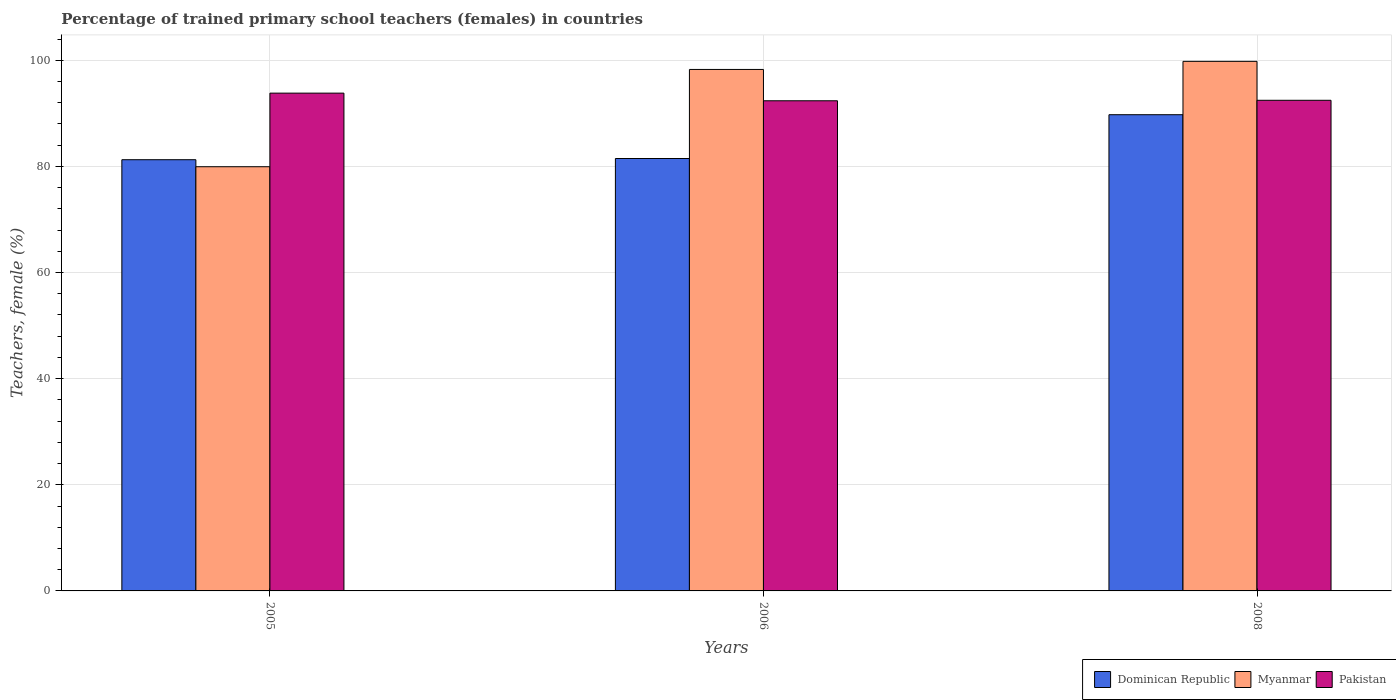How many groups of bars are there?
Give a very brief answer. 3. Are the number of bars per tick equal to the number of legend labels?
Your answer should be compact. Yes. How many bars are there on the 2nd tick from the right?
Your answer should be very brief. 3. In how many cases, is the number of bars for a given year not equal to the number of legend labels?
Provide a succinct answer. 0. What is the percentage of trained primary school teachers (females) in Myanmar in 2005?
Ensure brevity in your answer.  79.94. Across all years, what is the maximum percentage of trained primary school teachers (females) in Pakistan?
Your answer should be very brief. 93.81. Across all years, what is the minimum percentage of trained primary school teachers (females) in Pakistan?
Your response must be concise. 92.37. What is the total percentage of trained primary school teachers (females) in Pakistan in the graph?
Your answer should be very brief. 278.64. What is the difference between the percentage of trained primary school teachers (females) in Pakistan in 2006 and that in 2008?
Provide a short and direct response. -0.09. What is the difference between the percentage of trained primary school teachers (females) in Dominican Republic in 2008 and the percentage of trained primary school teachers (females) in Myanmar in 2006?
Provide a short and direct response. -8.53. What is the average percentage of trained primary school teachers (females) in Pakistan per year?
Keep it short and to the point. 92.88. In the year 2008, what is the difference between the percentage of trained primary school teachers (females) in Myanmar and percentage of trained primary school teachers (females) in Pakistan?
Ensure brevity in your answer.  7.34. What is the ratio of the percentage of trained primary school teachers (females) in Myanmar in 2005 to that in 2008?
Give a very brief answer. 0.8. What is the difference between the highest and the second highest percentage of trained primary school teachers (females) in Dominican Republic?
Your response must be concise. 8.25. What is the difference between the highest and the lowest percentage of trained primary school teachers (females) in Myanmar?
Your answer should be very brief. 19.86. In how many years, is the percentage of trained primary school teachers (females) in Myanmar greater than the average percentage of trained primary school teachers (females) in Myanmar taken over all years?
Ensure brevity in your answer.  2. What does the 1st bar from the left in 2005 represents?
Provide a short and direct response. Dominican Republic. What does the 1st bar from the right in 2008 represents?
Ensure brevity in your answer.  Pakistan. Is it the case that in every year, the sum of the percentage of trained primary school teachers (females) in Dominican Republic and percentage of trained primary school teachers (females) in Pakistan is greater than the percentage of trained primary school teachers (females) in Myanmar?
Ensure brevity in your answer.  Yes. How many bars are there?
Make the answer very short. 9. How many years are there in the graph?
Your answer should be compact. 3. What is the difference between two consecutive major ticks on the Y-axis?
Keep it short and to the point. 20. Are the values on the major ticks of Y-axis written in scientific E-notation?
Make the answer very short. No. Does the graph contain any zero values?
Your answer should be compact. No. Where does the legend appear in the graph?
Your answer should be very brief. Bottom right. How are the legend labels stacked?
Make the answer very short. Horizontal. What is the title of the graph?
Keep it short and to the point. Percentage of trained primary school teachers (females) in countries. What is the label or title of the X-axis?
Ensure brevity in your answer.  Years. What is the label or title of the Y-axis?
Provide a succinct answer. Teachers, female (%). What is the Teachers, female (%) in Dominican Republic in 2005?
Your response must be concise. 81.26. What is the Teachers, female (%) in Myanmar in 2005?
Give a very brief answer. 79.94. What is the Teachers, female (%) in Pakistan in 2005?
Your response must be concise. 93.81. What is the Teachers, female (%) of Dominican Republic in 2006?
Provide a succinct answer. 81.49. What is the Teachers, female (%) in Myanmar in 2006?
Your answer should be very brief. 98.27. What is the Teachers, female (%) in Pakistan in 2006?
Give a very brief answer. 92.37. What is the Teachers, female (%) of Dominican Republic in 2008?
Your answer should be very brief. 89.74. What is the Teachers, female (%) of Myanmar in 2008?
Your answer should be compact. 99.8. What is the Teachers, female (%) of Pakistan in 2008?
Your answer should be very brief. 92.46. Across all years, what is the maximum Teachers, female (%) in Dominican Republic?
Ensure brevity in your answer.  89.74. Across all years, what is the maximum Teachers, female (%) of Myanmar?
Ensure brevity in your answer.  99.8. Across all years, what is the maximum Teachers, female (%) of Pakistan?
Give a very brief answer. 93.81. Across all years, what is the minimum Teachers, female (%) of Dominican Republic?
Give a very brief answer. 81.26. Across all years, what is the minimum Teachers, female (%) of Myanmar?
Offer a very short reply. 79.94. Across all years, what is the minimum Teachers, female (%) in Pakistan?
Offer a terse response. 92.37. What is the total Teachers, female (%) of Dominican Republic in the graph?
Offer a terse response. 252.49. What is the total Teachers, female (%) in Myanmar in the graph?
Offer a terse response. 278.01. What is the total Teachers, female (%) in Pakistan in the graph?
Your answer should be very brief. 278.64. What is the difference between the Teachers, female (%) of Dominican Republic in 2005 and that in 2006?
Your answer should be compact. -0.23. What is the difference between the Teachers, female (%) in Myanmar in 2005 and that in 2006?
Your answer should be very brief. -18.33. What is the difference between the Teachers, female (%) of Pakistan in 2005 and that in 2006?
Provide a succinct answer. 1.44. What is the difference between the Teachers, female (%) in Dominican Republic in 2005 and that in 2008?
Give a very brief answer. -8.48. What is the difference between the Teachers, female (%) of Myanmar in 2005 and that in 2008?
Give a very brief answer. -19.86. What is the difference between the Teachers, female (%) in Pakistan in 2005 and that in 2008?
Make the answer very short. 1.35. What is the difference between the Teachers, female (%) in Dominican Republic in 2006 and that in 2008?
Keep it short and to the point. -8.25. What is the difference between the Teachers, female (%) in Myanmar in 2006 and that in 2008?
Provide a succinct answer. -1.52. What is the difference between the Teachers, female (%) in Pakistan in 2006 and that in 2008?
Offer a terse response. -0.09. What is the difference between the Teachers, female (%) of Dominican Republic in 2005 and the Teachers, female (%) of Myanmar in 2006?
Ensure brevity in your answer.  -17.01. What is the difference between the Teachers, female (%) of Dominican Republic in 2005 and the Teachers, female (%) of Pakistan in 2006?
Offer a very short reply. -11.11. What is the difference between the Teachers, female (%) of Myanmar in 2005 and the Teachers, female (%) of Pakistan in 2006?
Provide a short and direct response. -12.43. What is the difference between the Teachers, female (%) in Dominican Republic in 2005 and the Teachers, female (%) in Myanmar in 2008?
Give a very brief answer. -18.54. What is the difference between the Teachers, female (%) in Dominican Republic in 2005 and the Teachers, female (%) in Pakistan in 2008?
Ensure brevity in your answer.  -11.2. What is the difference between the Teachers, female (%) of Myanmar in 2005 and the Teachers, female (%) of Pakistan in 2008?
Your answer should be compact. -12.52. What is the difference between the Teachers, female (%) of Dominican Republic in 2006 and the Teachers, female (%) of Myanmar in 2008?
Provide a succinct answer. -18.31. What is the difference between the Teachers, female (%) in Dominican Republic in 2006 and the Teachers, female (%) in Pakistan in 2008?
Your answer should be very brief. -10.97. What is the difference between the Teachers, female (%) in Myanmar in 2006 and the Teachers, female (%) in Pakistan in 2008?
Your response must be concise. 5.81. What is the average Teachers, female (%) of Dominican Republic per year?
Offer a terse response. 84.16. What is the average Teachers, female (%) in Myanmar per year?
Keep it short and to the point. 92.67. What is the average Teachers, female (%) of Pakistan per year?
Provide a short and direct response. 92.88. In the year 2005, what is the difference between the Teachers, female (%) in Dominican Republic and Teachers, female (%) in Myanmar?
Your answer should be compact. 1.32. In the year 2005, what is the difference between the Teachers, female (%) of Dominican Republic and Teachers, female (%) of Pakistan?
Provide a succinct answer. -12.55. In the year 2005, what is the difference between the Teachers, female (%) in Myanmar and Teachers, female (%) in Pakistan?
Make the answer very short. -13.87. In the year 2006, what is the difference between the Teachers, female (%) of Dominican Republic and Teachers, female (%) of Myanmar?
Provide a short and direct response. -16.79. In the year 2006, what is the difference between the Teachers, female (%) in Dominican Republic and Teachers, female (%) in Pakistan?
Provide a short and direct response. -10.88. In the year 2006, what is the difference between the Teachers, female (%) in Myanmar and Teachers, female (%) in Pakistan?
Offer a very short reply. 5.9. In the year 2008, what is the difference between the Teachers, female (%) of Dominican Republic and Teachers, female (%) of Myanmar?
Ensure brevity in your answer.  -10.05. In the year 2008, what is the difference between the Teachers, female (%) in Dominican Republic and Teachers, female (%) in Pakistan?
Provide a succinct answer. -2.72. In the year 2008, what is the difference between the Teachers, female (%) of Myanmar and Teachers, female (%) of Pakistan?
Offer a very short reply. 7.34. What is the ratio of the Teachers, female (%) of Myanmar in 2005 to that in 2006?
Ensure brevity in your answer.  0.81. What is the ratio of the Teachers, female (%) in Pakistan in 2005 to that in 2006?
Ensure brevity in your answer.  1.02. What is the ratio of the Teachers, female (%) in Dominican Republic in 2005 to that in 2008?
Your response must be concise. 0.91. What is the ratio of the Teachers, female (%) in Myanmar in 2005 to that in 2008?
Your response must be concise. 0.8. What is the ratio of the Teachers, female (%) of Pakistan in 2005 to that in 2008?
Make the answer very short. 1.01. What is the ratio of the Teachers, female (%) of Dominican Republic in 2006 to that in 2008?
Your response must be concise. 0.91. What is the ratio of the Teachers, female (%) of Myanmar in 2006 to that in 2008?
Make the answer very short. 0.98. What is the difference between the highest and the second highest Teachers, female (%) in Dominican Republic?
Your answer should be compact. 8.25. What is the difference between the highest and the second highest Teachers, female (%) of Myanmar?
Your response must be concise. 1.52. What is the difference between the highest and the second highest Teachers, female (%) of Pakistan?
Keep it short and to the point. 1.35. What is the difference between the highest and the lowest Teachers, female (%) of Dominican Republic?
Your answer should be compact. 8.48. What is the difference between the highest and the lowest Teachers, female (%) of Myanmar?
Ensure brevity in your answer.  19.86. What is the difference between the highest and the lowest Teachers, female (%) in Pakistan?
Make the answer very short. 1.44. 